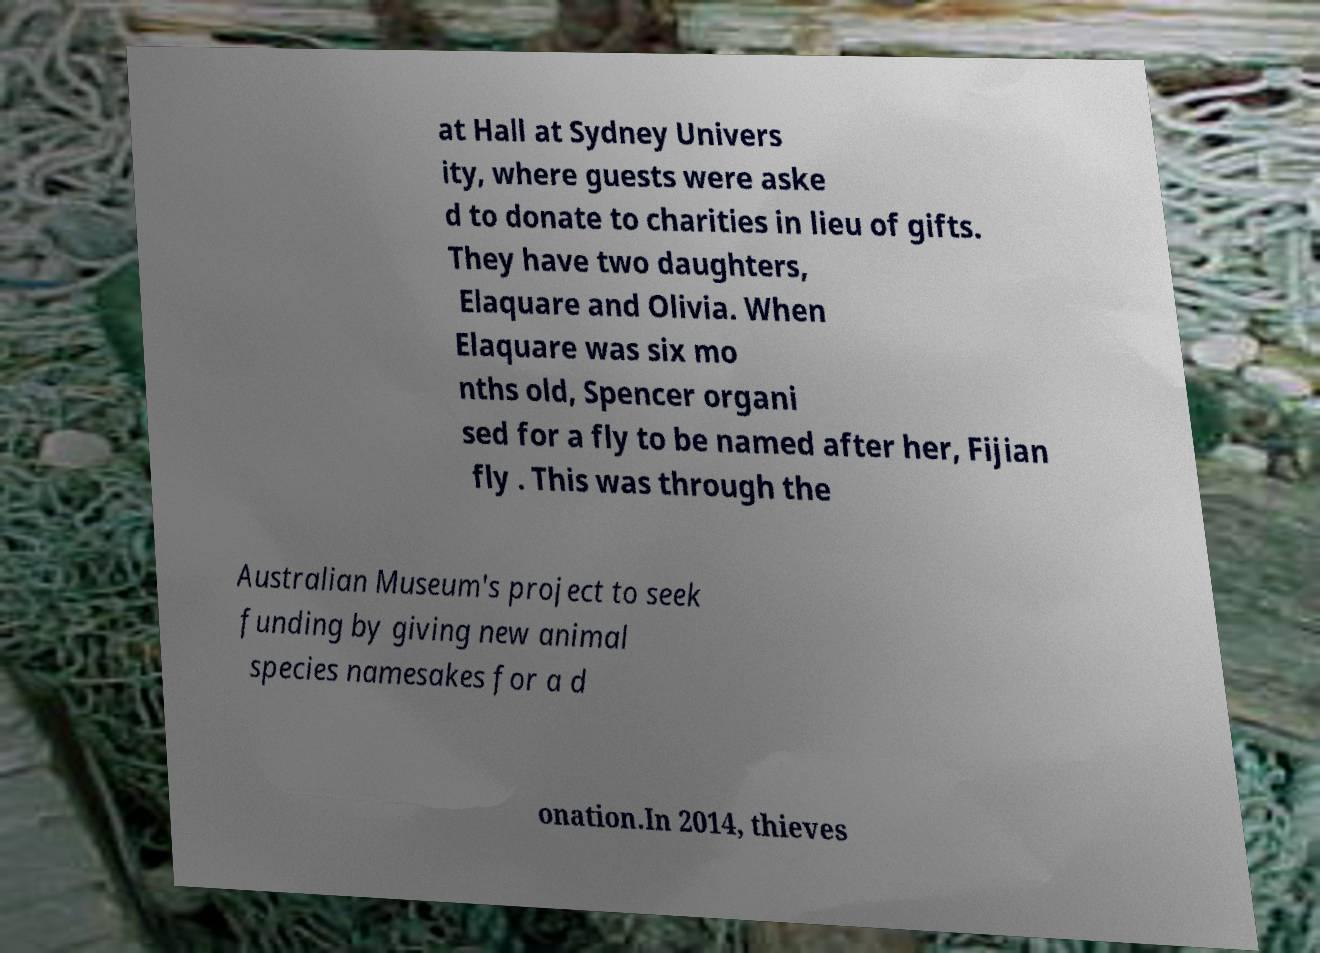Can you read and provide the text displayed in the image?This photo seems to have some interesting text. Can you extract and type it out for me? at Hall at Sydney Univers ity, where guests were aske d to donate to charities in lieu of gifts. They have two daughters, Elaquare and Olivia. When Elaquare was six mo nths old, Spencer organi sed for a fly to be named after her, Fijian fly . This was through the Australian Museum's project to seek funding by giving new animal species namesakes for a d onation.In 2014, thieves 